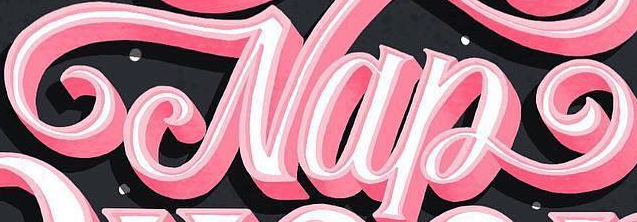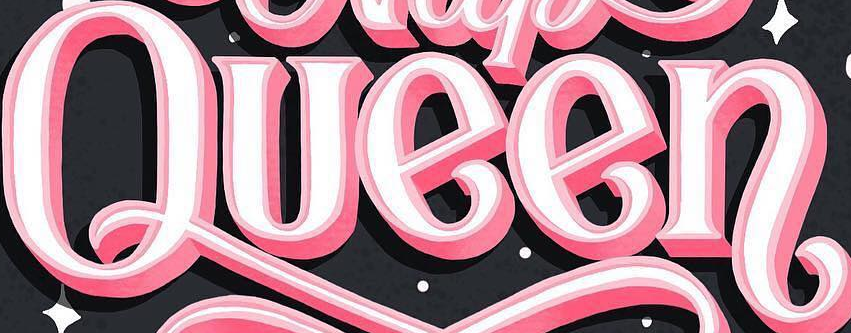What words can you see in these images in sequence, separated by a semicolon? Nap; Queen 